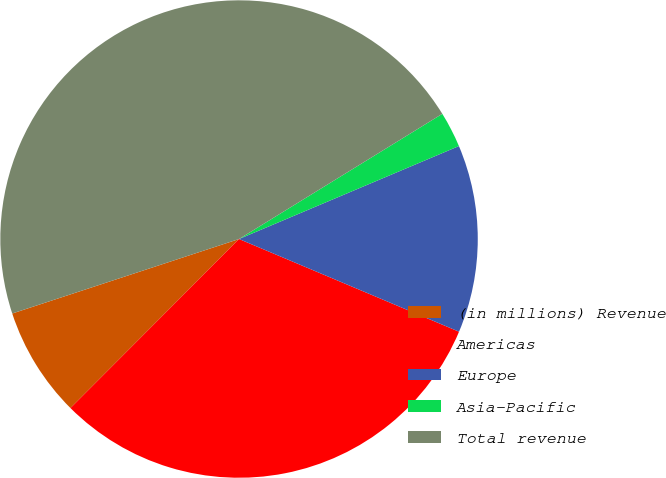<chart> <loc_0><loc_0><loc_500><loc_500><pie_chart><fcel>(in millions) Revenue<fcel>Americas<fcel>Europe<fcel>Asia-Pacific<fcel>Total revenue<nl><fcel>7.47%<fcel>31.13%<fcel>12.71%<fcel>2.42%<fcel>46.26%<nl></chart> 